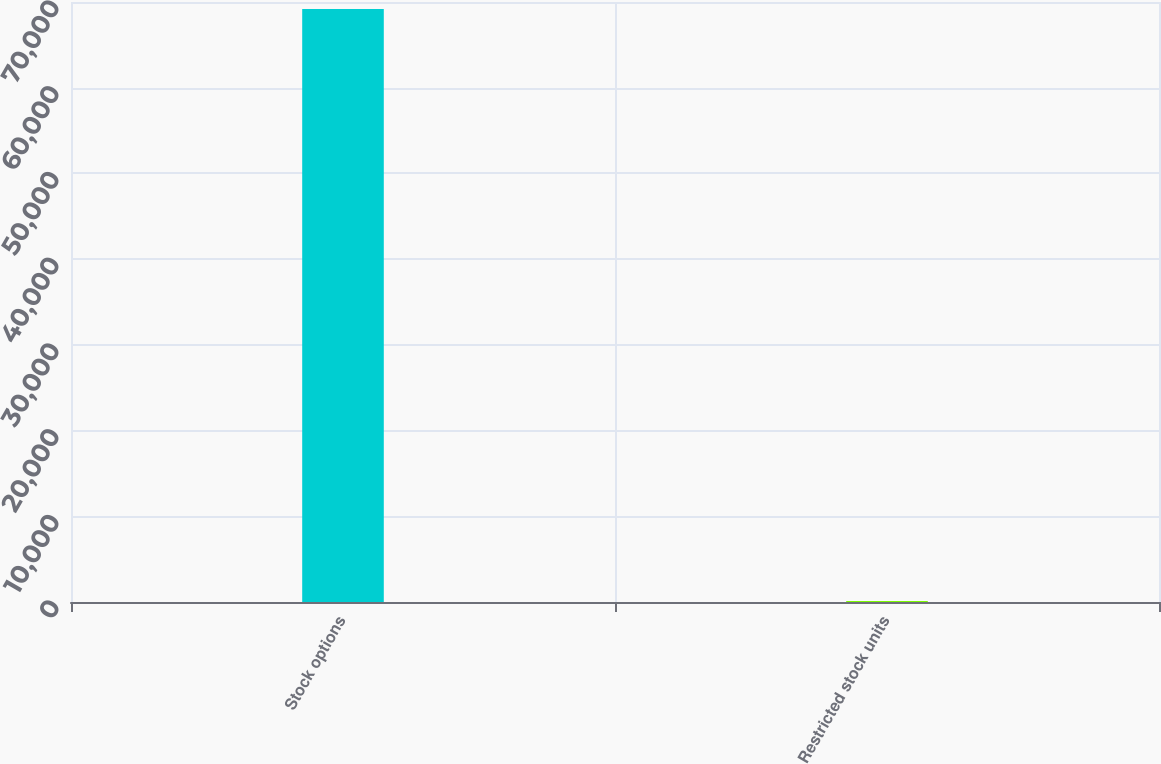<chart> <loc_0><loc_0><loc_500><loc_500><bar_chart><fcel>Stock options<fcel>Restricted stock units<nl><fcel>69186<fcel>109<nl></chart> 